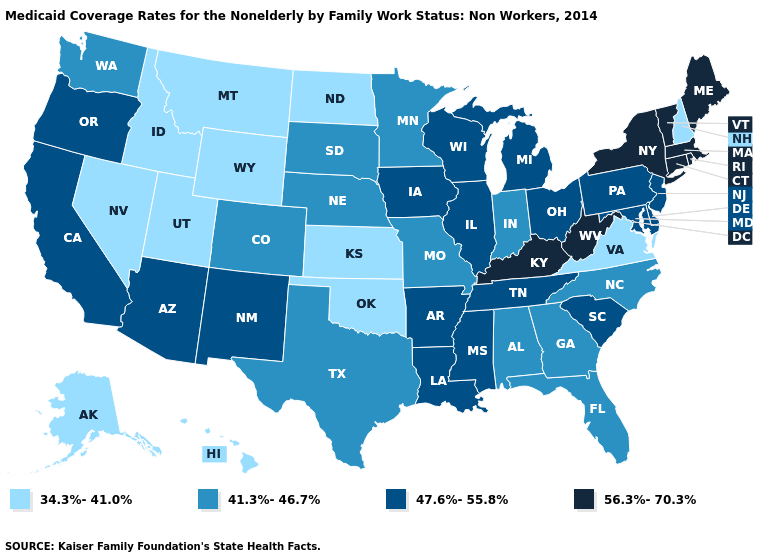What is the value of New Mexico?
Give a very brief answer. 47.6%-55.8%. Which states have the lowest value in the MidWest?
Keep it brief. Kansas, North Dakota. What is the highest value in the West ?
Keep it brief. 47.6%-55.8%. Which states have the highest value in the USA?
Keep it brief. Connecticut, Kentucky, Maine, Massachusetts, New York, Rhode Island, Vermont, West Virginia. Name the states that have a value in the range 47.6%-55.8%?
Keep it brief. Arizona, Arkansas, California, Delaware, Illinois, Iowa, Louisiana, Maryland, Michigan, Mississippi, New Jersey, New Mexico, Ohio, Oregon, Pennsylvania, South Carolina, Tennessee, Wisconsin. Does New York have the highest value in the USA?
Concise answer only. Yes. Which states have the lowest value in the West?
Answer briefly. Alaska, Hawaii, Idaho, Montana, Nevada, Utah, Wyoming. Does the map have missing data?
Answer briefly. No. Does the map have missing data?
Concise answer only. No. Name the states that have a value in the range 41.3%-46.7%?
Be succinct. Alabama, Colorado, Florida, Georgia, Indiana, Minnesota, Missouri, Nebraska, North Carolina, South Dakota, Texas, Washington. Does Illinois have a higher value than Nebraska?
Answer briefly. Yes. Does Vermont have the lowest value in the Northeast?
Concise answer only. No. Does Alabama have a higher value than Virginia?
Short answer required. Yes. Which states hav the highest value in the MidWest?
Quick response, please. Illinois, Iowa, Michigan, Ohio, Wisconsin. What is the value of Virginia?
Keep it brief. 34.3%-41.0%. 